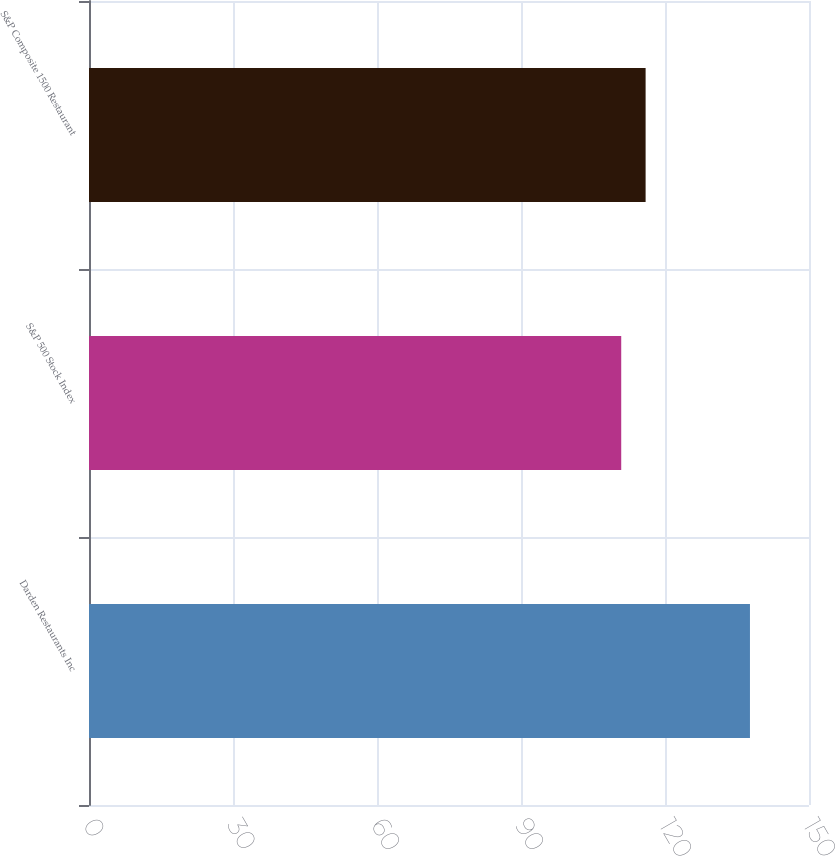Convert chart. <chart><loc_0><loc_0><loc_500><loc_500><bar_chart><fcel>Darden Restaurants Inc<fcel>S&P 500 Stock Index<fcel>S&P Composite 1500 Restaurant<nl><fcel>137.7<fcel>110.88<fcel>115.96<nl></chart> 